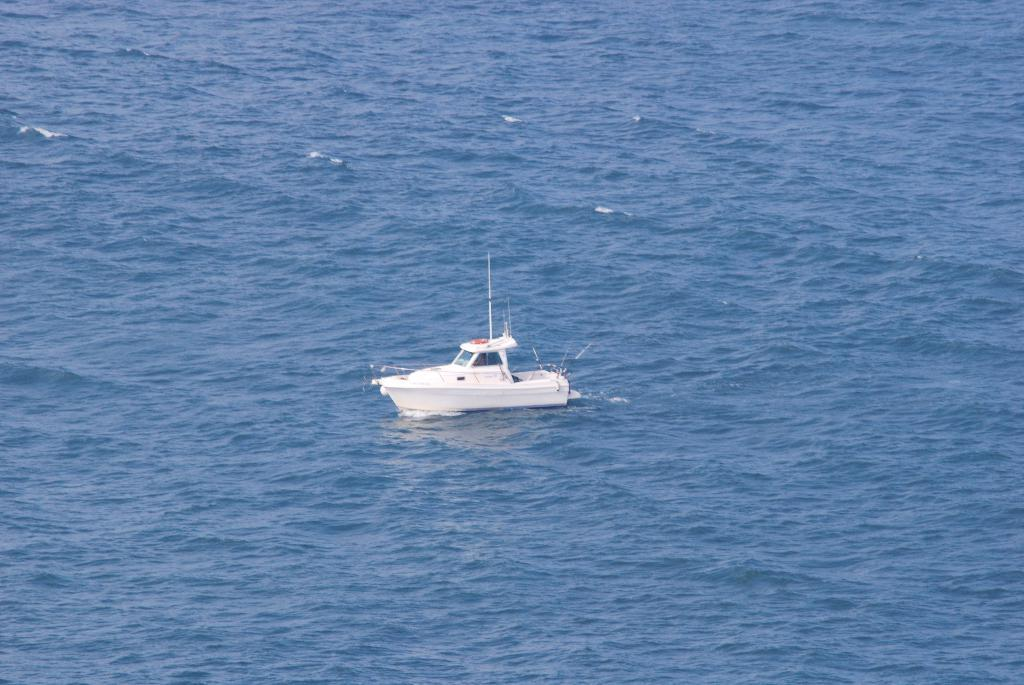What type of vehicle is in the image? There is a white boat in the image. What is the boat's position relative to the water? The boat is above the water. What color is the sock hanging in the garden near the boat? There is no sock or garden present in the image; it only features a white boat above the water. 